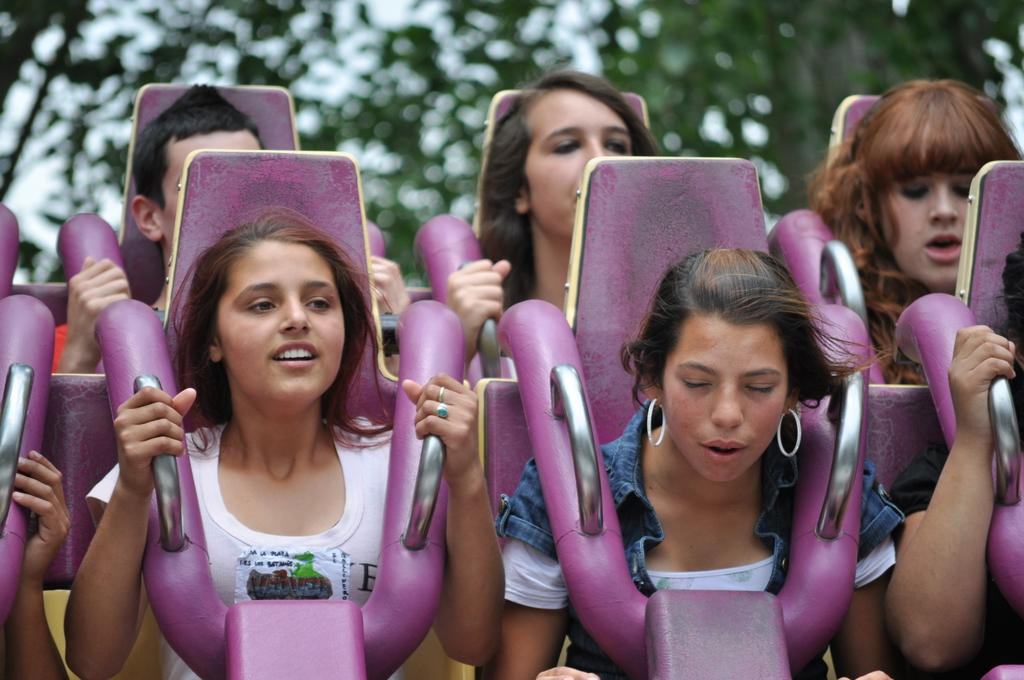What are the people in the foreground of the image doing? The people in the foreground of the image are sitting in chairs. What might be the theme or event depicted in the image? The scene might be an equinox, which is commonly displayed in exhibitions. What type of environment can be seen in the background of the image? There is greenery in the background of the image. How many tests were conducted during the event in the image? There is no mention of tests in the image, so it is not possible to answer this question. 